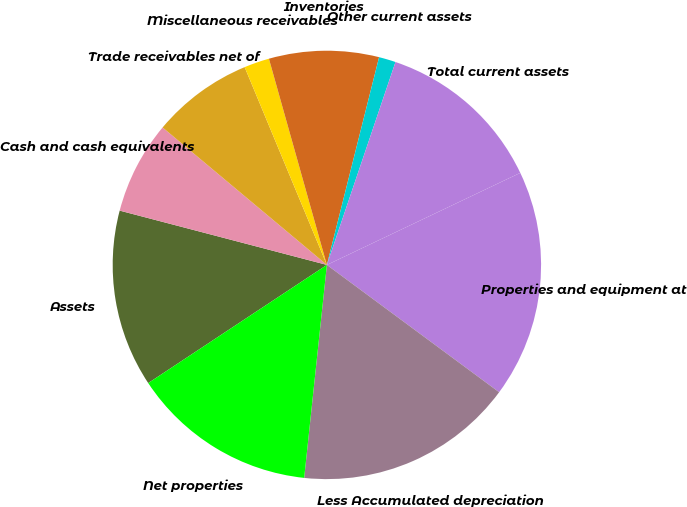Convert chart. <chart><loc_0><loc_0><loc_500><loc_500><pie_chart><fcel>Assets<fcel>Cash and cash equivalents<fcel>Trade receivables net of<fcel>Miscellaneous receivables<fcel>Inventories<fcel>Other current assets<fcel>Total current assets<fcel>Properties and equipment at<fcel>Less Accumulated depreciation<fcel>Net properties<nl><fcel>13.38%<fcel>7.01%<fcel>7.64%<fcel>1.91%<fcel>8.28%<fcel>1.27%<fcel>12.74%<fcel>17.2%<fcel>16.56%<fcel>14.01%<nl></chart> 